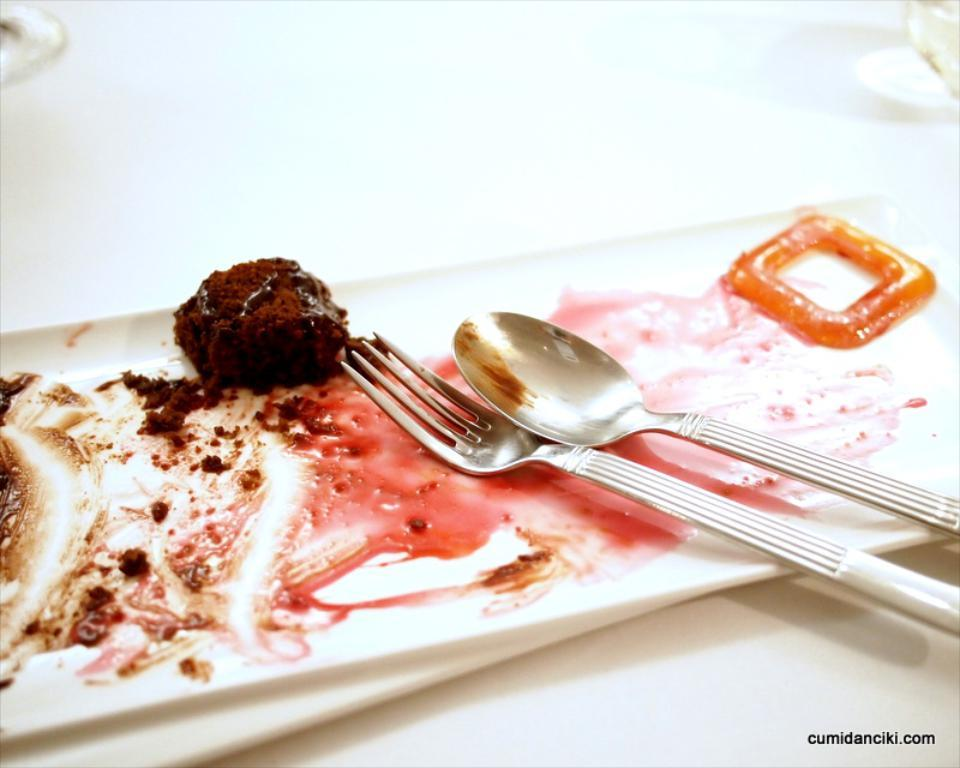What is on the plate that is visible in the image? There is a plate with food in the image. What utensils are on the plate? There is a spoon and a fork on the plate. What color is the surface on which the plate is placed? The plate is on a white color surface. Where is the nearest library to the location of the plate in the image? There is no information about the location of the plate or the nearest library in the image. 